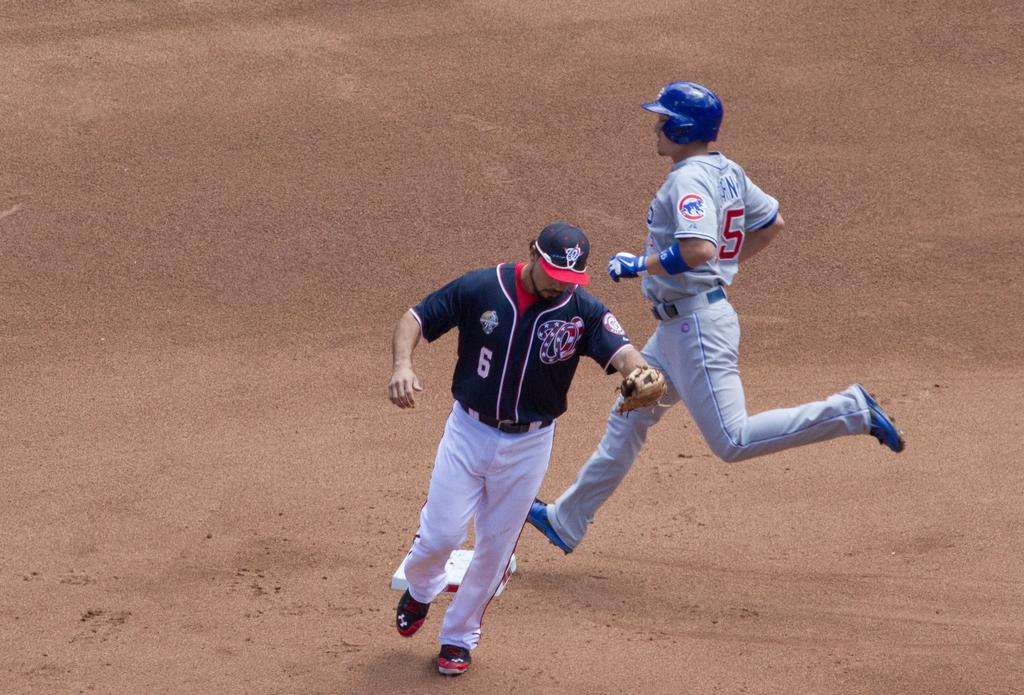<image>
Give a short and clear explanation of the subsequent image. A player wearing number 6 for the Nationals  is rounding the bases 